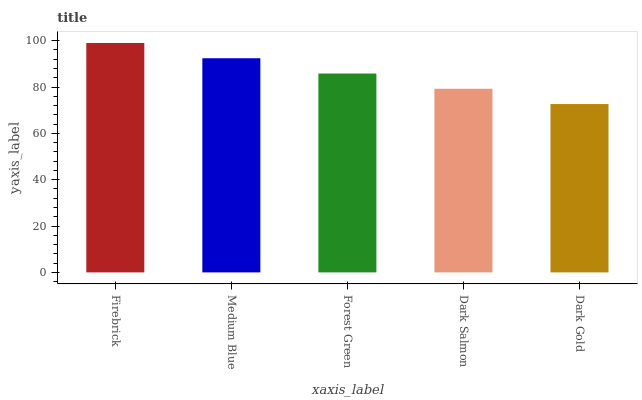Is Dark Gold the minimum?
Answer yes or no. Yes. Is Firebrick the maximum?
Answer yes or no. Yes. Is Medium Blue the minimum?
Answer yes or no. No. Is Medium Blue the maximum?
Answer yes or no. No. Is Firebrick greater than Medium Blue?
Answer yes or no. Yes. Is Medium Blue less than Firebrick?
Answer yes or no. Yes. Is Medium Blue greater than Firebrick?
Answer yes or no. No. Is Firebrick less than Medium Blue?
Answer yes or no. No. Is Forest Green the high median?
Answer yes or no. Yes. Is Forest Green the low median?
Answer yes or no. Yes. Is Dark Gold the high median?
Answer yes or no. No. Is Dark Gold the low median?
Answer yes or no. No. 